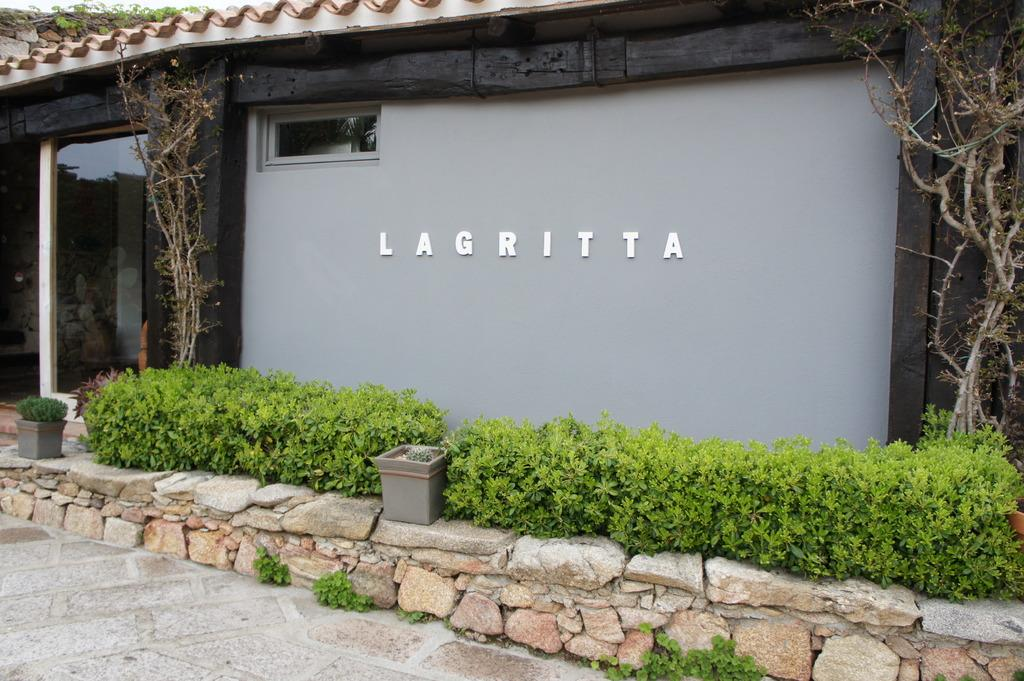What type of natural elements can be seen in the image? There are stones, plants, and trees in the image. What type of containers are present in the image? There are pots in the image. What type of structure is visible in the image? There is a house in the image. What type of material is present in the image? There is glass in the image. What architectural feature is visible in the image? There is a window in the image. What type of written information is present in the image? There is text on a wall in the image. What type of story is being told on the board in the image? There is no board present in the image, so no story can be observed. How is the distribution of the stones in the image? The distribution of the stones cannot be determined from the image alone, as it only shows their presence and not their arrangement. 